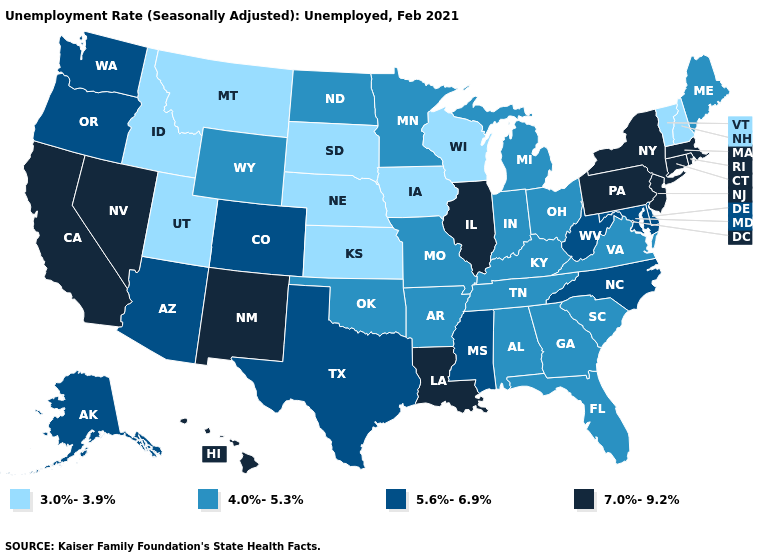How many symbols are there in the legend?
Be succinct. 4. Does Ohio have the highest value in the USA?
Short answer required. No. Name the states that have a value in the range 4.0%-5.3%?
Answer briefly. Alabama, Arkansas, Florida, Georgia, Indiana, Kentucky, Maine, Michigan, Minnesota, Missouri, North Dakota, Ohio, Oklahoma, South Carolina, Tennessee, Virginia, Wyoming. Name the states that have a value in the range 7.0%-9.2%?
Write a very short answer. California, Connecticut, Hawaii, Illinois, Louisiana, Massachusetts, Nevada, New Jersey, New Mexico, New York, Pennsylvania, Rhode Island. Does Wyoming have a higher value than Oregon?
Give a very brief answer. No. Among the states that border Louisiana , which have the highest value?
Be succinct. Mississippi, Texas. Name the states that have a value in the range 7.0%-9.2%?
Concise answer only. California, Connecticut, Hawaii, Illinois, Louisiana, Massachusetts, Nevada, New Jersey, New Mexico, New York, Pennsylvania, Rhode Island. Which states have the lowest value in the USA?
Concise answer only. Idaho, Iowa, Kansas, Montana, Nebraska, New Hampshire, South Dakota, Utah, Vermont, Wisconsin. Name the states that have a value in the range 4.0%-5.3%?
Concise answer only. Alabama, Arkansas, Florida, Georgia, Indiana, Kentucky, Maine, Michigan, Minnesota, Missouri, North Dakota, Ohio, Oklahoma, South Carolina, Tennessee, Virginia, Wyoming. What is the value of New Jersey?
Keep it brief. 7.0%-9.2%. What is the highest value in the USA?
Short answer required. 7.0%-9.2%. Does Hawaii have the lowest value in the USA?
Quick response, please. No. Among the states that border Colorado , does New Mexico have the highest value?
Keep it brief. Yes. Among the states that border New York , does Vermont have the lowest value?
Answer briefly. Yes. What is the lowest value in the USA?
Quick response, please. 3.0%-3.9%. 